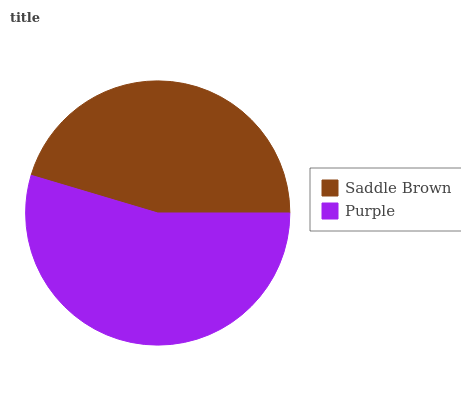Is Saddle Brown the minimum?
Answer yes or no. Yes. Is Purple the maximum?
Answer yes or no. Yes. Is Purple the minimum?
Answer yes or no. No. Is Purple greater than Saddle Brown?
Answer yes or no. Yes. Is Saddle Brown less than Purple?
Answer yes or no. Yes. Is Saddle Brown greater than Purple?
Answer yes or no. No. Is Purple less than Saddle Brown?
Answer yes or no. No. Is Purple the high median?
Answer yes or no. Yes. Is Saddle Brown the low median?
Answer yes or no. Yes. Is Saddle Brown the high median?
Answer yes or no. No. Is Purple the low median?
Answer yes or no. No. 